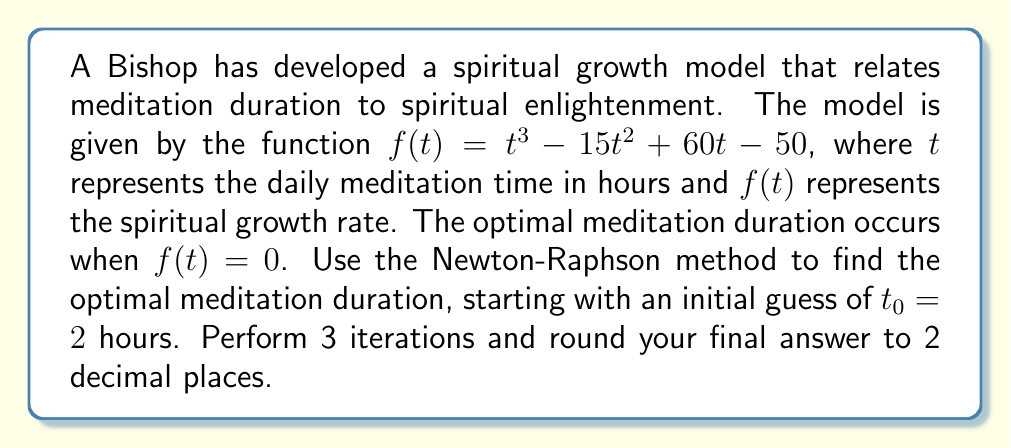Show me your answer to this math problem. To solve this problem using the Newton-Raphson method, we follow these steps:

1. The Newton-Raphson formula is:
   $$t_{n+1} = t_n - \frac{f(t_n)}{f'(t_n)}$$

2. We need to find $f'(t)$:
   $$f'(t) = 3t^2 - 30t + 60$$

3. Now, let's perform 3 iterations:

   Iteration 1:
   $$f(2) = 2^3 - 15(2^2) + 60(2) - 50 = 8 - 60 + 120 - 50 = 18$$
   $$f'(2) = 3(2^2) - 30(2) + 60 = 12 - 60 + 60 = 12$$
   $$t_1 = 2 - \frac{18}{12} = 2 - 1.5 = 0.5$$

   Iteration 2:
   $$f(0.5) = 0.5^3 - 15(0.5^2) + 60(0.5) - 50 = 0.125 - 3.75 + 30 - 50 = -23.625$$
   $$f'(0.5) = 3(0.5^2) - 30(0.5) + 60 = 0.75 - 15 + 60 = 45.75$$
   $$t_2 = 0.5 - \frac{-23.625}{45.75} = 0.5 + 0.5164 = 1.0164$$

   Iteration 3:
   $$f(1.0164) = 1.0164^3 - 15(1.0164^2) + 60(1.0164) - 50 = -0.1559$$
   $$f'(1.0164) = 3(1.0164^2) - 30(1.0164) + 60 = 32.9934$$
   $$t_3 = 1.0164 - \frac{-0.1559}{32.9934} = 1.0164 + 0.0047 = 1.0211$$

4. Rounding to 2 decimal places, we get 1.02 hours.
Answer: 1.02 hours 